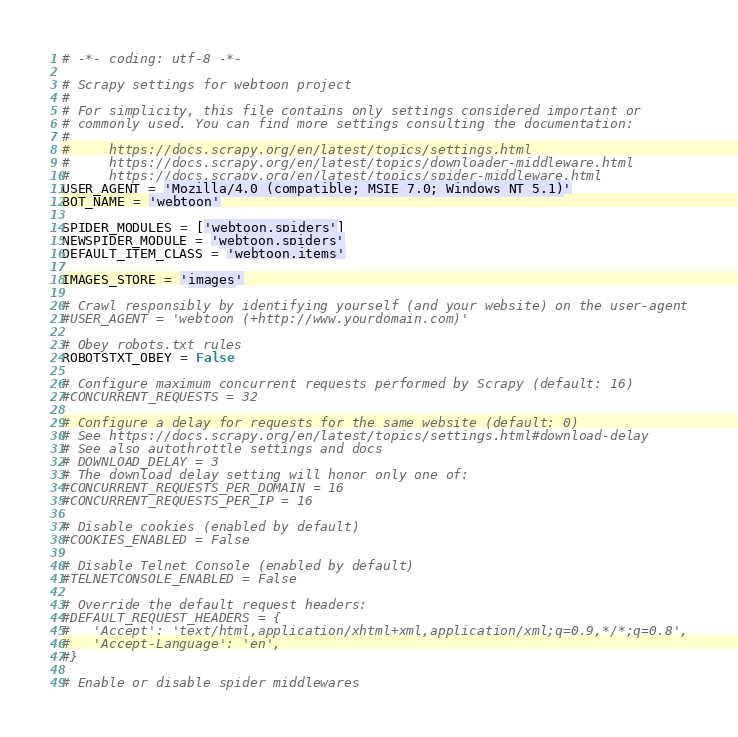<code> <loc_0><loc_0><loc_500><loc_500><_Python_># -*- coding: utf-8 -*-

# Scrapy settings for webtoon project
#
# For simplicity, this file contains only settings considered important or
# commonly used. You can find more settings consulting the documentation:
#
#     https://docs.scrapy.org/en/latest/topics/settings.html
#     https://docs.scrapy.org/en/latest/topics/downloader-middleware.html
#     https://docs.scrapy.org/en/latest/topics/spider-middleware.html
USER_AGENT = 'Mozilla/4.0 (compatible; MSIE 7.0; Windows NT 5.1)'
BOT_NAME = 'webtoon'

SPIDER_MODULES = ['webtoon.spiders']
NEWSPIDER_MODULE = 'webtoon.spiders'
DEFAULT_ITEM_CLASS = 'webtoon.items'

IMAGES_STORE = 'images'

# Crawl responsibly by identifying yourself (and your website) on the user-agent
#USER_AGENT = 'webtoon (+http://www.yourdomain.com)'

# Obey robots.txt rules
ROBOTSTXT_OBEY = False

# Configure maximum concurrent requests performed by Scrapy (default: 16)
#CONCURRENT_REQUESTS = 32

# Configure a delay for requests for the same website (default: 0)
# See https://docs.scrapy.org/en/latest/topics/settings.html#download-delay
# See also autothrottle settings and docs
# DOWNLOAD_DELAY = 3
# The download delay setting will honor only one of:
#CONCURRENT_REQUESTS_PER_DOMAIN = 16
#CONCURRENT_REQUESTS_PER_IP = 16

# Disable cookies (enabled by default)
#COOKIES_ENABLED = False

# Disable Telnet Console (enabled by default)
#TELNETCONSOLE_ENABLED = False

# Override the default request headers:
#DEFAULT_REQUEST_HEADERS = {
#   'Accept': 'text/html,application/xhtml+xml,application/xml;q=0.9,*/*;q=0.8',
#   'Accept-Language': 'en',
#}

# Enable or disable spider middlewares</code> 